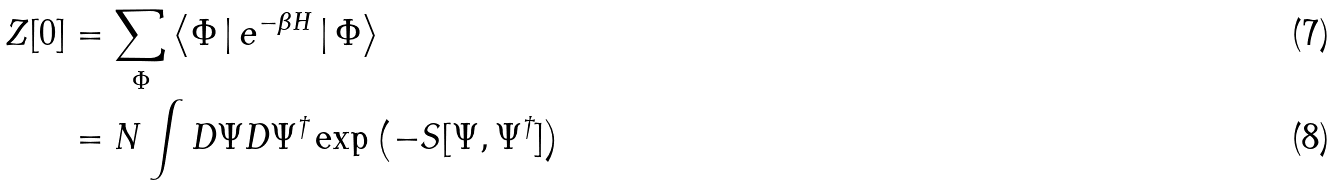Convert formula to latex. <formula><loc_0><loc_0><loc_500><loc_500>Z [ 0 ] & = \sum _ { \Phi } \left \langle { \Phi } \, | \, e ^ { - \beta H } \, | \, { \Phi } \right \rangle \\ & = N \int D \Psi D { \Psi } ^ { \dagger } \exp \left ( { - S [ \Psi , \Psi ^ { \dagger } ] } \right )</formula> 